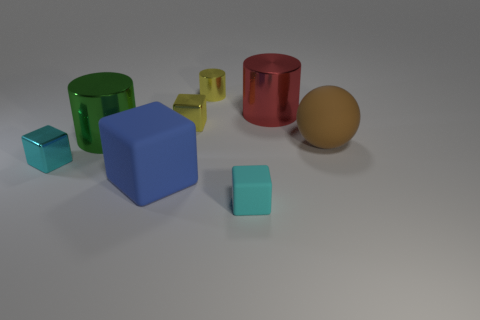What number of yellow metal cylinders are behind the large thing that is in front of the large brown matte object?
Keep it short and to the point. 1. What number of metal things are either large cubes or tiny brown spheres?
Your answer should be compact. 0. Is there a sphere made of the same material as the large blue cube?
Keep it short and to the point. Yes. How many objects are large metal cylinders that are to the left of the cyan matte block or things to the right of the red cylinder?
Your response must be concise. 2. Is the color of the object left of the big green thing the same as the large rubber ball?
Provide a short and direct response. No. What number of other objects are the same color as the big matte cube?
Make the answer very short. 0. What is the large blue block made of?
Make the answer very short. Rubber. There is a cube behind the brown thing; does it have the same size as the small rubber block?
Your answer should be compact. Yes. Is there anything else that has the same size as the ball?
Ensure brevity in your answer.  Yes. There is a cyan metal object that is the same shape as the large blue matte object; what size is it?
Offer a very short reply. Small. 